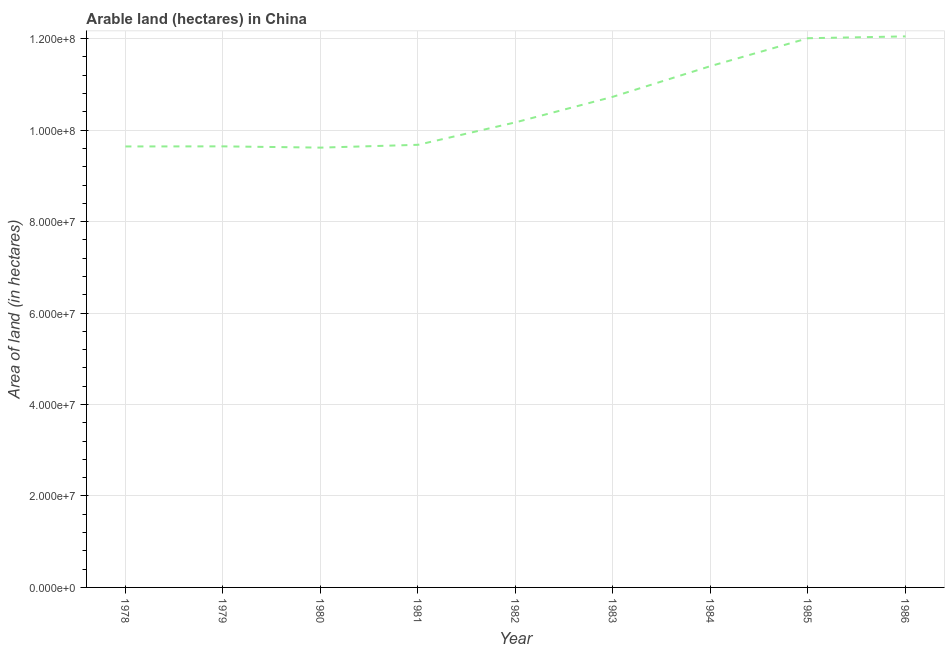What is the area of land in 1983?
Give a very brief answer. 1.07e+08. Across all years, what is the maximum area of land?
Ensure brevity in your answer.  1.20e+08. Across all years, what is the minimum area of land?
Your answer should be compact. 9.62e+07. What is the sum of the area of land?
Ensure brevity in your answer.  9.49e+08. What is the difference between the area of land in 1980 and 1983?
Make the answer very short. -1.11e+07. What is the average area of land per year?
Your answer should be very brief. 1.05e+08. What is the median area of land?
Offer a terse response. 1.02e+08. In how many years, is the area of land greater than 32000000 hectares?
Offer a terse response. 9. What is the ratio of the area of land in 1983 to that in 1984?
Your response must be concise. 0.94. Is the area of land in 1979 less than that in 1980?
Provide a succinct answer. No. What is the difference between the highest and the lowest area of land?
Your answer should be compact. 2.43e+07. Are the values on the major ticks of Y-axis written in scientific E-notation?
Provide a succinct answer. Yes. Does the graph contain any zero values?
Your answer should be compact. No. What is the title of the graph?
Provide a succinct answer. Arable land (hectares) in China. What is the label or title of the X-axis?
Offer a very short reply. Year. What is the label or title of the Y-axis?
Offer a very short reply. Area of land (in hectares). What is the Area of land (in hectares) of 1978?
Keep it short and to the point. 9.64e+07. What is the Area of land (in hectares) of 1979?
Your answer should be very brief. 9.65e+07. What is the Area of land (in hectares) of 1980?
Keep it short and to the point. 9.62e+07. What is the Area of land (in hectares) in 1981?
Your answer should be compact. 9.68e+07. What is the Area of land (in hectares) in 1982?
Offer a terse response. 1.02e+08. What is the Area of land (in hectares) in 1983?
Make the answer very short. 1.07e+08. What is the Area of land (in hectares) of 1984?
Provide a short and direct response. 1.14e+08. What is the Area of land (in hectares) of 1985?
Provide a succinct answer. 1.20e+08. What is the Area of land (in hectares) of 1986?
Your response must be concise. 1.20e+08. What is the difference between the Area of land (in hectares) in 1978 and 1979?
Provide a short and direct response. -2.20e+04. What is the difference between the Area of land (in hectares) in 1978 and 1980?
Offer a terse response. 2.55e+05. What is the difference between the Area of land (in hectares) in 1978 and 1981?
Ensure brevity in your answer.  -3.60e+05. What is the difference between the Area of land (in hectares) in 1978 and 1982?
Give a very brief answer. -5.27e+06. What is the difference between the Area of land (in hectares) in 1978 and 1983?
Ensure brevity in your answer.  -1.09e+07. What is the difference between the Area of land (in hectares) in 1978 and 1984?
Offer a terse response. -1.76e+07. What is the difference between the Area of land (in hectares) in 1978 and 1985?
Keep it short and to the point. -2.37e+07. What is the difference between the Area of land (in hectares) in 1978 and 1986?
Your response must be concise. -2.41e+07. What is the difference between the Area of land (in hectares) in 1979 and 1980?
Ensure brevity in your answer.  2.77e+05. What is the difference between the Area of land (in hectares) in 1979 and 1981?
Make the answer very short. -3.38e+05. What is the difference between the Area of land (in hectares) in 1979 and 1982?
Give a very brief answer. -5.25e+06. What is the difference between the Area of land (in hectares) in 1979 and 1983?
Make the answer very short. -1.08e+07. What is the difference between the Area of land (in hectares) in 1979 and 1984?
Ensure brevity in your answer.  -1.75e+07. What is the difference between the Area of land (in hectares) in 1979 and 1985?
Ensure brevity in your answer.  -2.36e+07. What is the difference between the Area of land (in hectares) in 1979 and 1986?
Provide a short and direct response. -2.40e+07. What is the difference between the Area of land (in hectares) in 1980 and 1981?
Make the answer very short. -6.15e+05. What is the difference between the Area of land (in hectares) in 1980 and 1982?
Keep it short and to the point. -5.52e+06. What is the difference between the Area of land (in hectares) in 1980 and 1983?
Your response must be concise. -1.11e+07. What is the difference between the Area of land (in hectares) in 1980 and 1984?
Your answer should be very brief. -1.78e+07. What is the difference between the Area of land (in hectares) in 1980 and 1985?
Keep it short and to the point. -2.39e+07. What is the difference between the Area of land (in hectares) in 1980 and 1986?
Your answer should be compact. -2.43e+07. What is the difference between the Area of land (in hectares) in 1981 and 1982?
Offer a terse response. -4.91e+06. What is the difference between the Area of land (in hectares) in 1981 and 1983?
Provide a short and direct response. -1.05e+07. What is the difference between the Area of land (in hectares) in 1981 and 1984?
Keep it short and to the point. -1.72e+07. What is the difference between the Area of land (in hectares) in 1981 and 1985?
Provide a short and direct response. -2.33e+07. What is the difference between the Area of land (in hectares) in 1981 and 1986?
Your response must be concise. -2.37e+07. What is the difference between the Area of land (in hectares) in 1982 and 1983?
Make the answer very short. -5.60e+06. What is the difference between the Area of land (in hectares) in 1982 and 1984?
Offer a very short reply. -1.23e+07. What is the difference between the Area of land (in hectares) in 1982 and 1985?
Give a very brief answer. -1.84e+07. What is the difference between the Area of land (in hectares) in 1982 and 1986?
Provide a short and direct response. -1.88e+07. What is the difference between the Area of land (in hectares) in 1983 and 1984?
Provide a short and direct response. -6.70e+06. What is the difference between the Area of land (in hectares) in 1983 and 1985?
Provide a short and direct response. -1.28e+07. What is the difference between the Area of land (in hectares) in 1983 and 1986?
Provide a short and direct response. -1.32e+07. What is the difference between the Area of land (in hectares) in 1984 and 1985?
Make the answer very short. -6.10e+06. What is the difference between the Area of land (in hectares) in 1984 and 1986?
Ensure brevity in your answer.  -6.50e+06. What is the difference between the Area of land (in hectares) in 1985 and 1986?
Ensure brevity in your answer.  -4.00e+05. What is the ratio of the Area of land (in hectares) in 1978 to that in 1980?
Provide a succinct answer. 1. What is the ratio of the Area of land (in hectares) in 1978 to that in 1982?
Offer a very short reply. 0.95. What is the ratio of the Area of land (in hectares) in 1978 to that in 1983?
Provide a succinct answer. 0.9. What is the ratio of the Area of land (in hectares) in 1978 to that in 1984?
Make the answer very short. 0.85. What is the ratio of the Area of land (in hectares) in 1978 to that in 1985?
Your answer should be compact. 0.8. What is the ratio of the Area of land (in hectares) in 1978 to that in 1986?
Make the answer very short. 0.8. What is the ratio of the Area of land (in hectares) in 1979 to that in 1982?
Provide a short and direct response. 0.95. What is the ratio of the Area of land (in hectares) in 1979 to that in 1983?
Make the answer very short. 0.9. What is the ratio of the Area of land (in hectares) in 1979 to that in 1984?
Your answer should be compact. 0.85. What is the ratio of the Area of land (in hectares) in 1979 to that in 1985?
Keep it short and to the point. 0.8. What is the ratio of the Area of land (in hectares) in 1980 to that in 1982?
Keep it short and to the point. 0.95. What is the ratio of the Area of land (in hectares) in 1980 to that in 1983?
Offer a very short reply. 0.9. What is the ratio of the Area of land (in hectares) in 1980 to that in 1984?
Offer a terse response. 0.84. What is the ratio of the Area of land (in hectares) in 1980 to that in 1985?
Your response must be concise. 0.8. What is the ratio of the Area of land (in hectares) in 1980 to that in 1986?
Ensure brevity in your answer.  0.8. What is the ratio of the Area of land (in hectares) in 1981 to that in 1983?
Provide a succinct answer. 0.9. What is the ratio of the Area of land (in hectares) in 1981 to that in 1984?
Offer a terse response. 0.85. What is the ratio of the Area of land (in hectares) in 1981 to that in 1985?
Your answer should be very brief. 0.81. What is the ratio of the Area of land (in hectares) in 1981 to that in 1986?
Keep it short and to the point. 0.8. What is the ratio of the Area of land (in hectares) in 1982 to that in 1983?
Keep it short and to the point. 0.95. What is the ratio of the Area of land (in hectares) in 1982 to that in 1984?
Your response must be concise. 0.89. What is the ratio of the Area of land (in hectares) in 1982 to that in 1985?
Keep it short and to the point. 0.85. What is the ratio of the Area of land (in hectares) in 1982 to that in 1986?
Make the answer very short. 0.84. What is the ratio of the Area of land (in hectares) in 1983 to that in 1984?
Ensure brevity in your answer.  0.94. What is the ratio of the Area of land (in hectares) in 1983 to that in 1985?
Offer a very short reply. 0.89. What is the ratio of the Area of land (in hectares) in 1983 to that in 1986?
Provide a succinct answer. 0.89. What is the ratio of the Area of land (in hectares) in 1984 to that in 1985?
Make the answer very short. 0.95. What is the ratio of the Area of land (in hectares) in 1984 to that in 1986?
Offer a terse response. 0.95. 